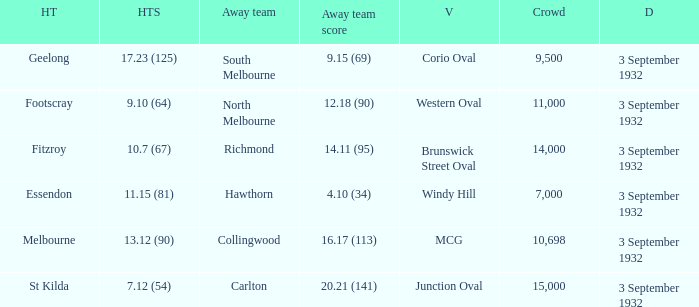What date is listed for the team that has an Away team score of 20.21 (141)? 3 September 1932. 